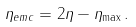Convert formula to latex. <formula><loc_0><loc_0><loc_500><loc_500>\eta _ { e m c } = 2 \eta - \eta _ { \max } \, .</formula> 